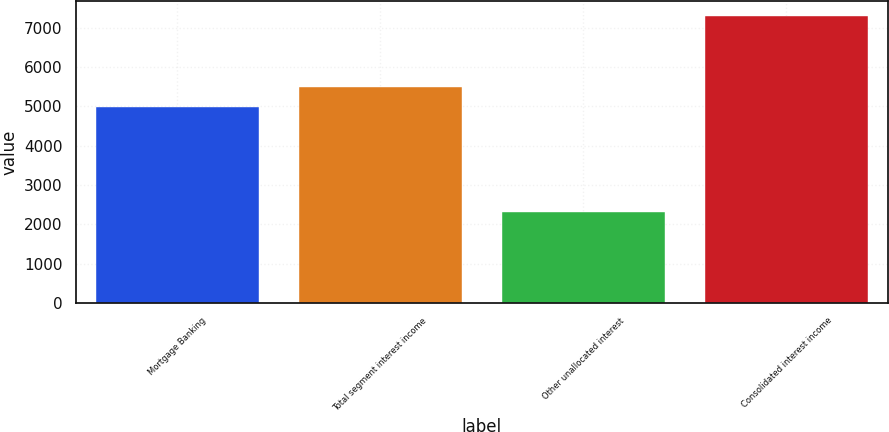Convert chart to OTSL. <chart><loc_0><loc_0><loc_500><loc_500><bar_chart><fcel>Mortgage Banking<fcel>Total segment interest income<fcel>Other unallocated interest<fcel>Consolidated interest income<nl><fcel>4983<fcel>5481.3<fcel>2319<fcel>7302<nl></chart> 